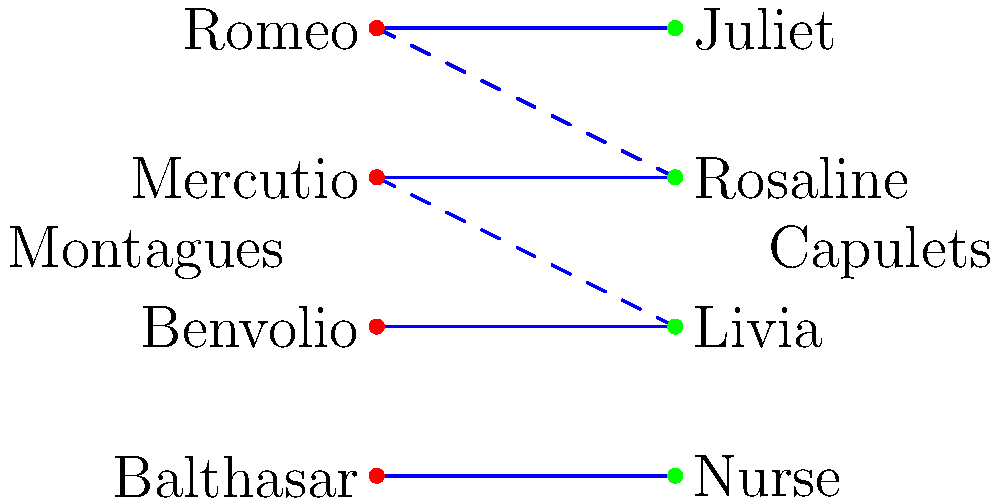In a Shakespearean-style play, four characters from the Montague family are to be paired with four characters from the Capulet family for a grand masked ball. The bipartite graph above shows the potential pairings, with solid lines indicating strong romantic connections and dashed lines representing weaker attractions. What is the maximum number of star-crossed lover pairs that can be formed, and which pairing ensures the most passionate encounters? To solve this problem, we need to find the maximum matching in the bipartite graph. Let's approach this step-by-step:

1. Identify the vertices: We have 4 Montagues (left side) and 4 Capulets (right side).

2. Count the edges:
   - Solid edges (strong connections): 4
   - Dashed edges (weak connections): 2

3. Find the maximum matching:
   a) Start with Romeo-Juliet (solid edge)
   b) Mercutio-Rosaline (solid edge)
   c) Benvolio-Livia (solid edge)
   d) Balthasar-Nurse (solid edge)

4. Verify the matching:
   - All vertices are matched
   - No two edges share a vertex
   - All edges are solid (strong connections)

5. Count the pairs: We have 4 pairs in total.

6. Optimal pairing:
   Romeo-Juliet
   Mercutio-Rosaline
   Benvolio-Livia
   Balthasar-Nurse

This pairing ensures the most passionate encounters as all connections are strong (solid lines).
Answer: 4 pairs; Romeo-Juliet, Mercutio-Rosaline, Benvolio-Livia, Balthasar-Nurse 